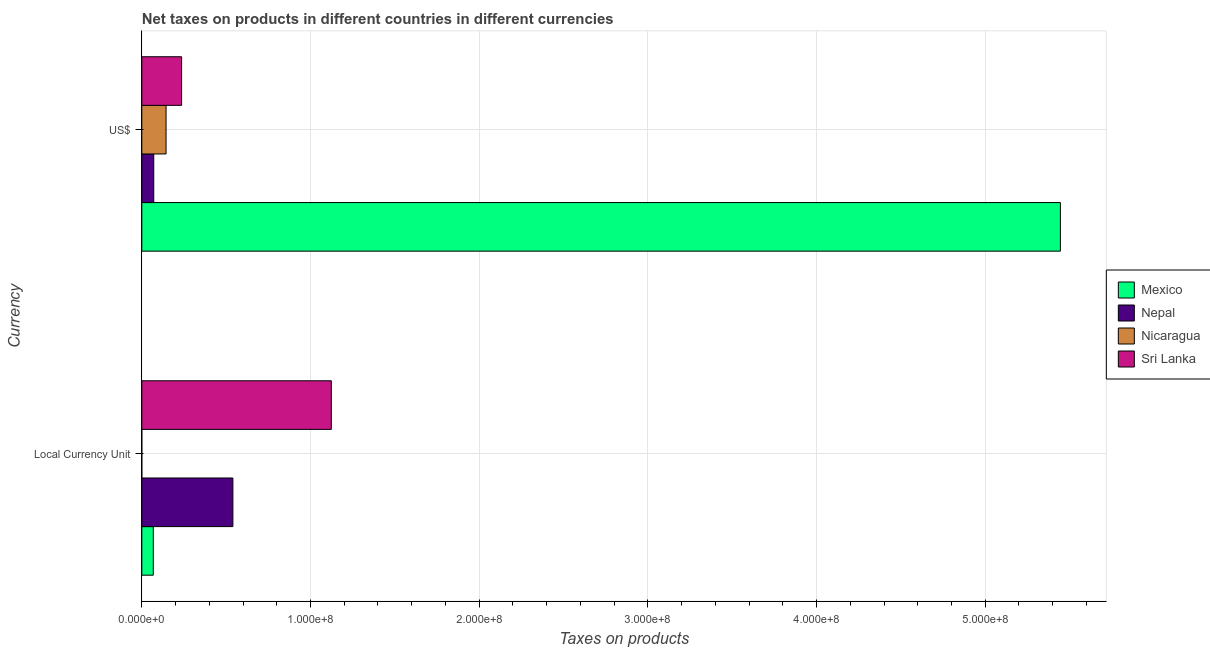How many different coloured bars are there?
Provide a short and direct response. 4. Are the number of bars per tick equal to the number of legend labels?
Make the answer very short. Yes. Are the number of bars on each tick of the Y-axis equal?
Offer a very short reply. Yes. How many bars are there on the 1st tick from the top?
Offer a very short reply. 4. How many bars are there on the 2nd tick from the bottom?
Give a very brief answer. 4. What is the label of the 1st group of bars from the top?
Ensure brevity in your answer.  US$. What is the net taxes in constant 2005 us$ in Nepal?
Your answer should be compact. 5.40e+07. Across all countries, what is the maximum net taxes in constant 2005 us$?
Keep it short and to the point. 1.12e+08. Across all countries, what is the minimum net taxes in us$?
Keep it short and to the point. 7.09e+06. In which country was the net taxes in constant 2005 us$ maximum?
Offer a very short reply. Sri Lanka. In which country was the net taxes in constant 2005 us$ minimum?
Ensure brevity in your answer.  Nicaragua. What is the total net taxes in constant 2005 us$ in the graph?
Offer a very short reply. 1.73e+08. What is the difference between the net taxes in us$ in Nepal and that in Mexico?
Make the answer very short. -5.37e+08. What is the difference between the net taxes in us$ in Nepal and the net taxes in constant 2005 us$ in Nicaragua?
Provide a short and direct response. 7.09e+06. What is the average net taxes in constant 2005 us$ per country?
Provide a succinct answer. 4.33e+07. What is the difference between the net taxes in constant 2005 us$ and net taxes in us$ in Sri Lanka?
Offer a very short reply. 8.88e+07. What is the ratio of the net taxes in us$ in Nicaragua to that in Nepal?
Ensure brevity in your answer.  2.03. Is the net taxes in us$ in Nepal less than that in Sri Lanka?
Your answer should be compact. Yes. In how many countries, is the net taxes in us$ greater than the average net taxes in us$ taken over all countries?
Provide a short and direct response. 1. What does the 3rd bar from the top in US$ represents?
Ensure brevity in your answer.  Nepal. What does the 2nd bar from the bottom in US$ represents?
Offer a terse response. Nepal. What is the difference between two consecutive major ticks on the X-axis?
Make the answer very short. 1.00e+08. Does the graph contain grids?
Ensure brevity in your answer.  Yes. Where does the legend appear in the graph?
Your answer should be very brief. Center right. How many legend labels are there?
Offer a very short reply. 4. How are the legend labels stacked?
Provide a short and direct response. Vertical. What is the title of the graph?
Give a very brief answer. Net taxes on products in different countries in different currencies. What is the label or title of the X-axis?
Keep it short and to the point. Taxes on products. What is the label or title of the Y-axis?
Provide a short and direct response. Currency. What is the Taxes on products of Mexico in Local Currency Unit?
Give a very brief answer. 6.81e+06. What is the Taxes on products in Nepal in Local Currency Unit?
Keep it short and to the point. 5.40e+07. What is the Taxes on products in Nicaragua in Local Currency Unit?
Give a very brief answer. 0.03. What is the Taxes on products in Sri Lanka in Local Currency Unit?
Make the answer very short. 1.12e+08. What is the Taxes on products of Mexico in US$?
Keep it short and to the point. 5.45e+08. What is the Taxes on products in Nepal in US$?
Provide a succinct answer. 7.09e+06. What is the Taxes on products in Nicaragua in US$?
Offer a terse response. 1.44e+07. What is the Taxes on products in Sri Lanka in US$?
Your answer should be compact. 2.36e+07. Across all Currency, what is the maximum Taxes on products of Mexico?
Offer a very short reply. 5.45e+08. Across all Currency, what is the maximum Taxes on products of Nepal?
Your answer should be very brief. 5.40e+07. Across all Currency, what is the maximum Taxes on products in Nicaragua?
Keep it short and to the point. 1.44e+07. Across all Currency, what is the maximum Taxes on products of Sri Lanka?
Offer a very short reply. 1.12e+08. Across all Currency, what is the minimum Taxes on products of Mexico?
Your answer should be compact. 6.81e+06. Across all Currency, what is the minimum Taxes on products in Nepal?
Ensure brevity in your answer.  7.09e+06. Across all Currency, what is the minimum Taxes on products of Nicaragua?
Provide a succinct answer. 0.03. Across all Currency, what is the minimum Taxes on products of Sri Lanka?
Your answer should be very brief. 2.36e+07. What is the total Taxes on products in Mexico in the graph?
Provide a succinct answer. 5.51e+08. What is the total Taxes on products of Nepal in the graph?
Offer a terse response. 6.11e+07. What is the total Taxes on products in Nicaragua in the graph?
Your answer should be very brief. 1.44e+07. What is the total Taxes on products of Sri Lanka in the graph?
Your answer should be very brief. 1.36e+08. What is the difference between the Taxes on products of Mexico in Local Currency Unit and that in US$?
Provide a succinct answer. -5.38e+08. What is the difference between the Taxes on products in Nepal in Local Currency Unit and that in US$?
Offer a very short reply. 4.69e+07. What is the difference between the Taxes on products in Nicaragua in Local Currency Unit and that in US$?
Provide a short and direct response. -1.44e+07. What is the difference between the Taxes on products in Sri Lanka in Local Currency Unit and that in US$?
Your answer should be compact. 8.88e+07. What is the difference between the Taxes on products in Mexico in Local Currency Unit and the Taxes on products in Nepal in US$?
Your answer should be compact. -2.80e+05. What is the difference between the Taxes on products in Mexico in Local Currency Unit and the Taxes on products in Nicaragua in US$?
Offer a terse response. -7.58e+06. What is the difference between the Taxes on products of Mexico in Local Currency Unit and the Taxes on products of Sri Lanka in US$?
Your response must be concise. -1.68e+07. What is the difference between the Taxes on products of Nepal in Local Currency Unit and the Taxes on products of Nicaragua in US$?
Give a very brief answer. 3.96e+07. What is the difference between the Taxes on products of Nepal in Local Currency Unit and the Taxes on products of Sri Lanka in US$?
Give a very brief answer. 3.04e+07. What is the difference between the Taxes on products in Nicaragua in Local Currency Unit and the Taxes on products in Sri Lanka in US$?
Your answer should be very brief. -2.36e+07. What is the average Taxes on products of Mexico per Currency?
Your answer should be compact. 2.76e+08. What is the average Taxes on products of Nepal per Currency?
Ensure brevity in your answer.  3.05e+07. What is the average Taxes on products in Nicaragua per Currency?
Offer a very short reply. 7.19e+06. What is the average Taxes on products in Sri Lanka per Currency?
Provide a short and direct response. 6.80e+07. What is the difference between the Taxes on products in Mexico and Taxes on products in Nepal in Local Currency Unit?
Your answer should be compact. -4.72e+07. What is the difference between the Taxes on products of Mexico and Taxes on products of Nicaragua in Local Currency Unit?
Your response must be concise. 6.81e+06. What is the difference between the Taxes on products of Mexico and Taxes on products of Sri Lanka in Local Currency Unit?
Your response must be concise. -1.06e+08. What is the difference between the Taxes on products of Nepal and Taxes on products of Nicaragua in Local Currency Unit?
Provide a succinct answer. 5.40e+07. What is the difference between the Taxes on products of Nepal and Taxes on products of Sri Lanka in Local Currency Unit?
Give a very brief answer. -5.84e+07. What is the difference between the Taxes on products in Nicaragua and Taxes on products in Sri Lanka in Local Currency Unit?
Your response must be concise. -1.12e+08. What is the difference between the Taxes on products of Mexico and Taxes on products of Nepal in US$?
Your answer should be very brief. 5.37e+08. What is the difference between the Taxes on products in Mexico and Taxes on products in Nicaragua in US$?
Offer a terse response. 5.30e+08. What is the difference between the Taxes on products of Mexico and Taxes on products of Sri Lanka in US$?
Your answer should be compact. 5.21e+08. What is the difference between the Taxes on products in Nepal and Taxes on products in Nicaragua in US$?
Provide a succinct answer. -7.30e+06. What is the difference between the Taxes on products in Nepal and Taxes on products in Sri Lanka in US$?
Make the answer very short. -1.65e+07. What is the difference between the Taxes on products in Nicaragua and Taxes on products in Sri Lanka in US$?
Your answer should be very brief. -9.22e+06. What is the ratio of the Taxes on products of Mexico in Local Currency Unit to that in US$?
Make the answer very short. 0.01. What is the ratio of the Taxes on products in Nepal in Local Currency Unit to that in US$?
Make the answer very short. 7.62. What is the ratio of the Taxes on products of Sri Lanka in Local Currency Unit to that in US$?
Give a very brief answer. 4.76. What is the difference between the highest and the second highest Taxes on products in Mexico?
Ensure brevity in your answer.  5.38e+08. What is the difference between the highest and the second highest Taxes on products in Nepal?
Keep it short and to the point. 4.69e+07. What is the difference between the highest and the second highest Taxes on products in Nicaragua?
Make the answer very short. 1.44e+07. What is the difference between the highest and the second highest Taxes on products in Sri Lanka?
Your answer should be compact. 8.88e+07. What is the difference between the highest and the lowest Taxes on products of Mexico?
Your answer should be very brief. 5.38e+08. What is the difference between the highest and the lowest Taxes on products in Nepal?
Provide a succinct answer. 4.69e+07. What is the difference between the highest and the lowest Taxes on products in Nicaragua?
Offer a terse response. 1.44e+07. What is the difference between the highest and the lowest Taxes on products in Sri Lanka?
Your response must be concise. 8.88e+07. 